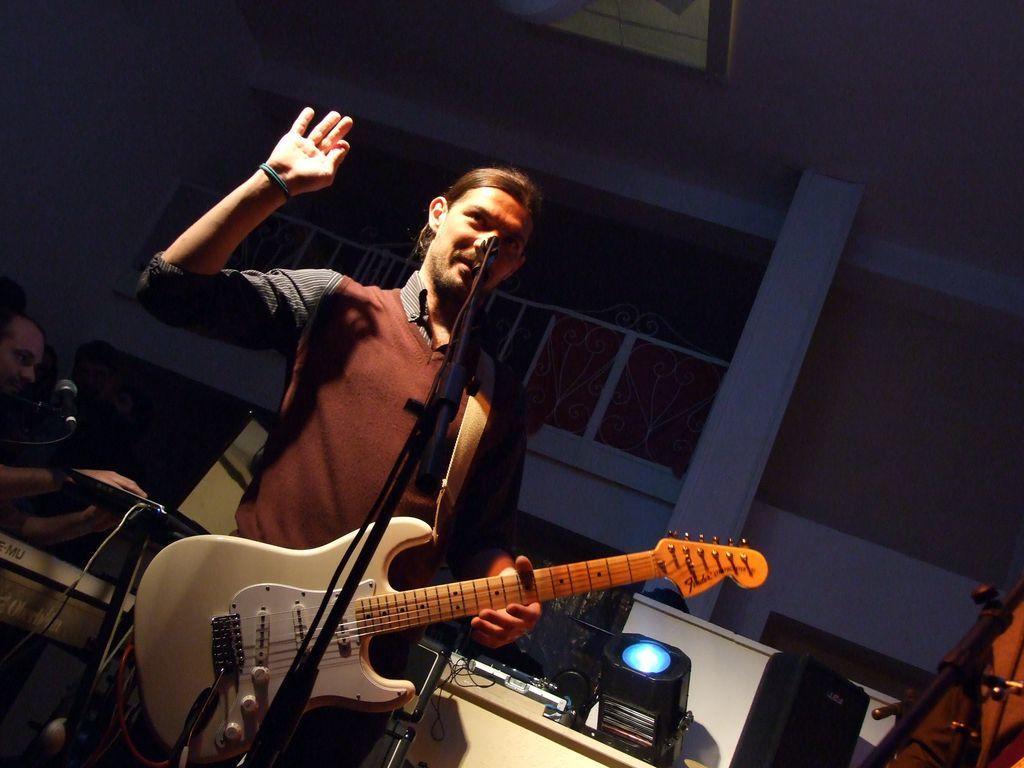Please provide a concise description of this image. This image is clicked in a musical concert where it has a person and Mike in the middle, that person is playing guitar. He is wearing brown colour sweater. There are people on the left side who are playing some musical instruments, a mike is on the left side , there is a light in the bottom. 